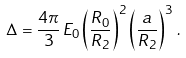<formula> <loc_0><loc_0><loc_500><loc_500>\Delta = \frac { 4 \pi } { 3 } \, E _ { 0 } \left ( \frac { R _ { 0 } } { R _ { 2 } } \right ) ^ { 2 } \left ( \frac { a } { R _ { 2 } } \right ) ^ { 3 } \, .</formula> 